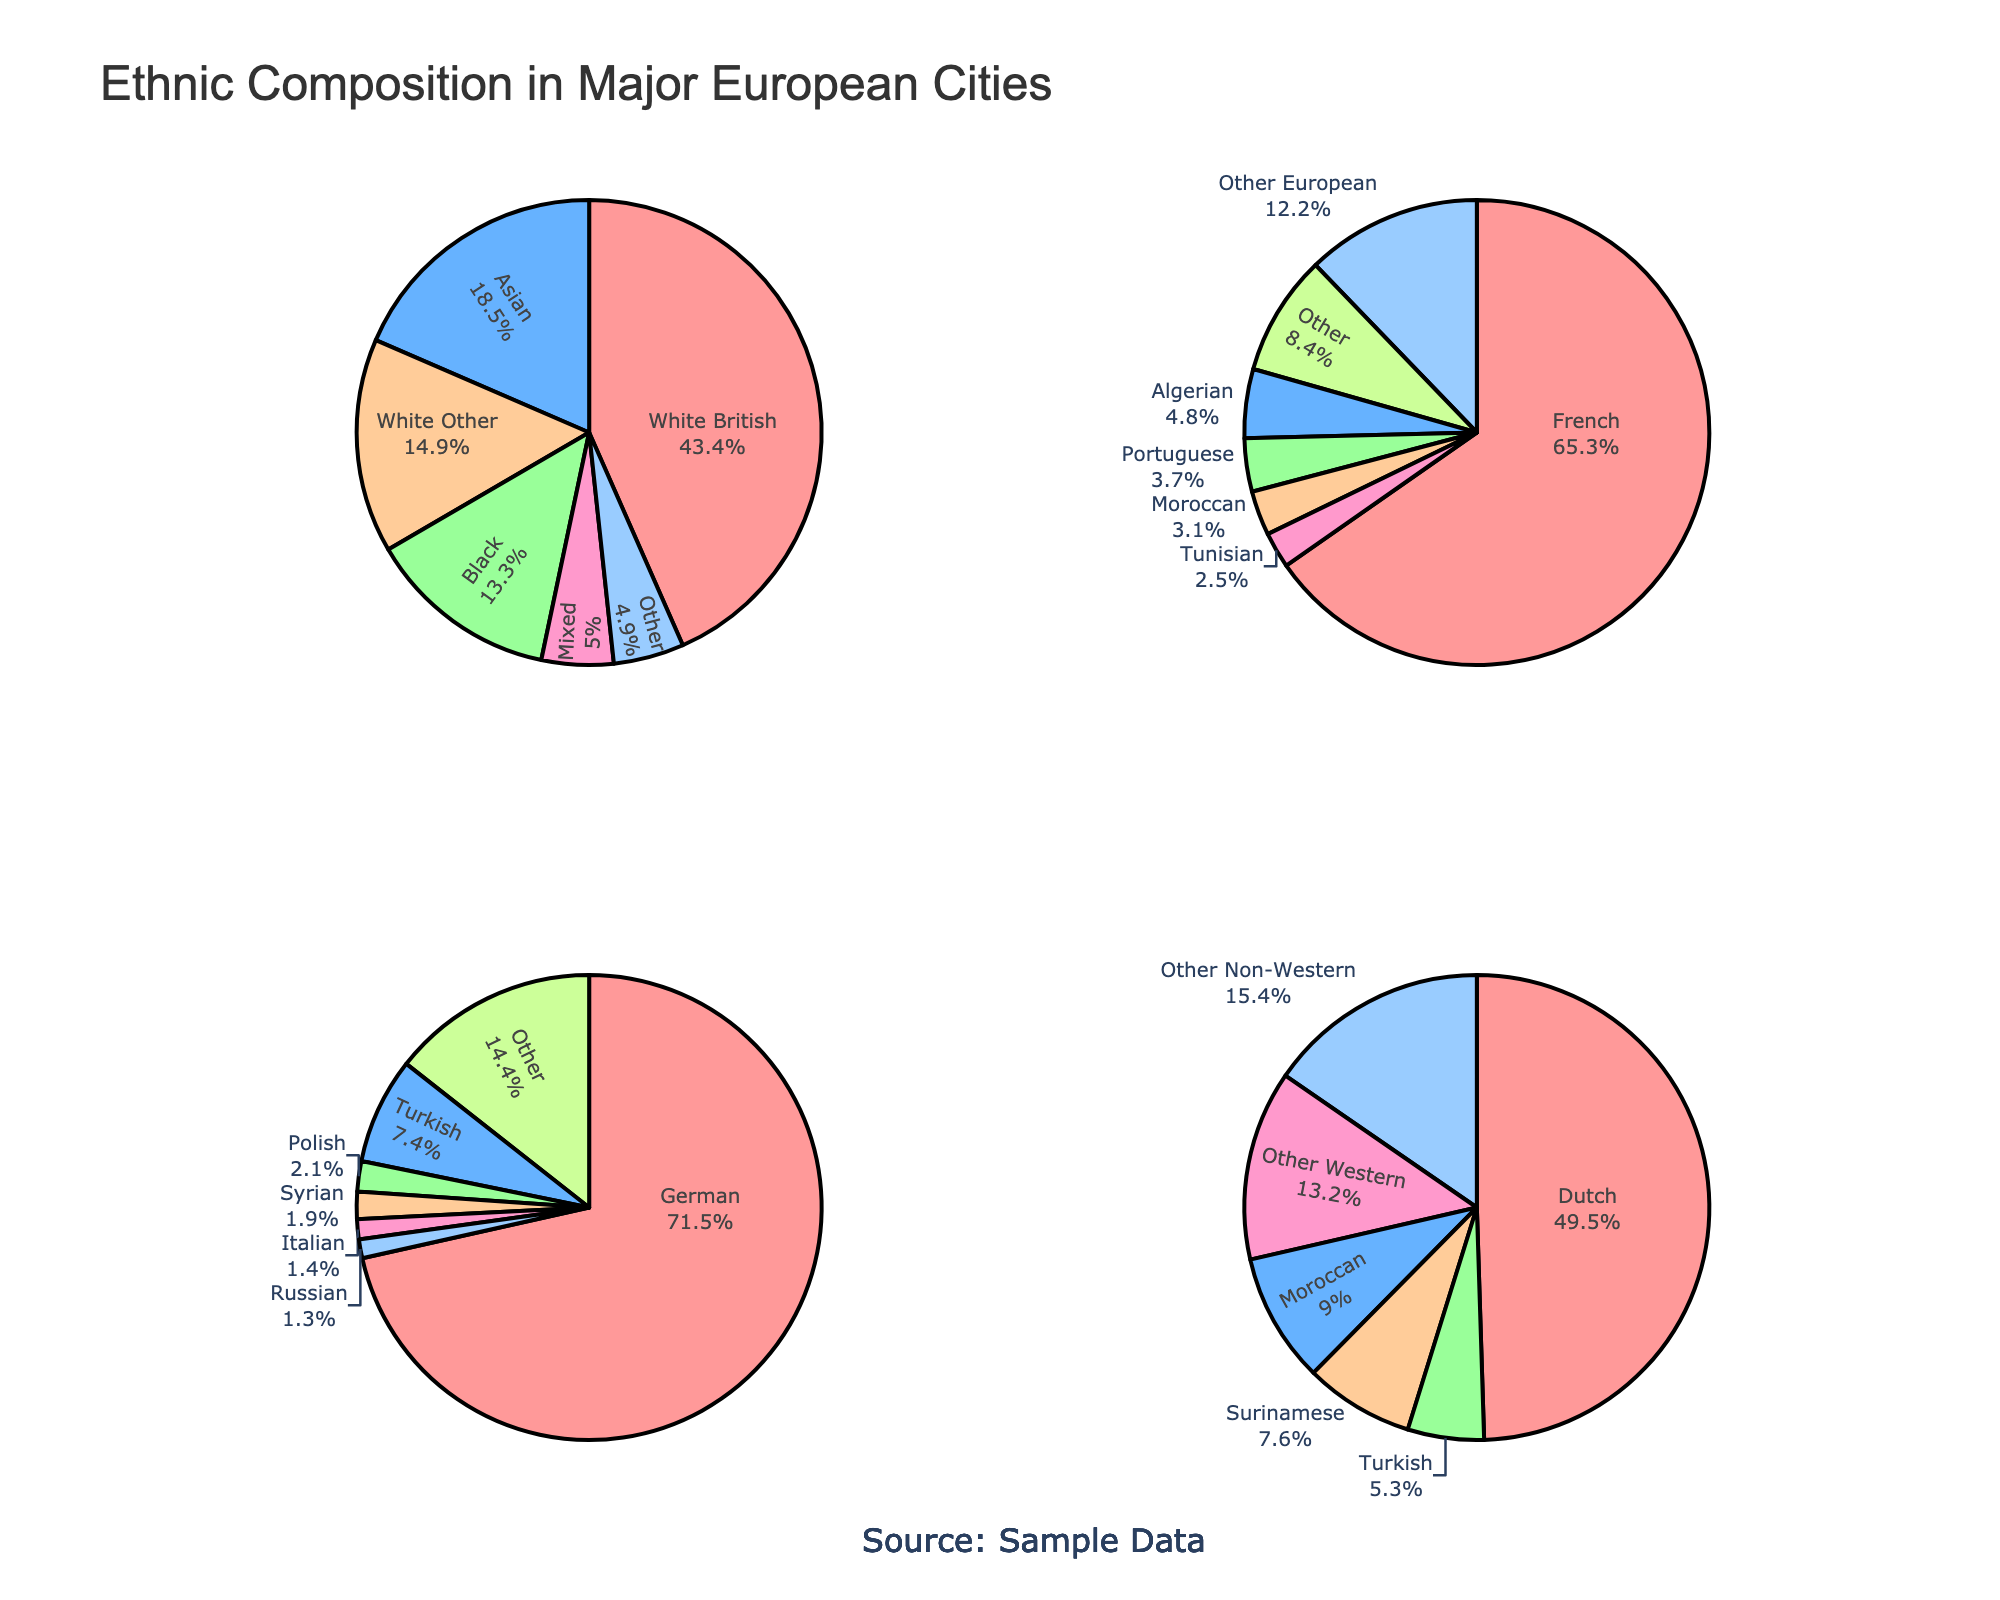What's the total percentage of ethnic groups categorized as "Other" in all four cities? To find the total percentage of ethnic groups categorized as "Other" for each city, we sum up the percentages: London (4.9), Paris (8.4), Berlin (14.4), and Amsterdam (15.4). Adding these values gives 4.9 + 8.4 + 14.4 + 15.4 = 43.1.
Answer: 43.1% Which city has the highest percentage of its largest ethnic group? London has 43.4% White British, Paris has 65.3% French, Berlin has 71.5% German, Amsterdam has 49.5% Dutch. Berlin has the highest percentage of its largest ethnic group at 71.5%.
Answer: Berlin How does the percentage of the Turkish ethnic group in Berlin compare to that in Amsterdam? The Turkish ethnic group is 7.4% in Berlin and 5.3% in Amsterdam. Hence, the percentage in Berlin is higher.
Answer: Berlin What is the combined percentage of "White Other" and "Mixed" ethnic groups in London? In London, "White Other" is 14.9% and "Mixed" is 5.0%. Combining these gives 14.9 + 5.0 = 19.9%.
Answer: 19.9% Among the four cities, which one has the smallest percentage of its second-largest ethnic group? London's second-largest group is Asian (18.5%), Paris’s is Other European (12.2%), Berlin’s is Turkish (7.4%), and Amsterdam’s is Moroccan (9.0%). Berlin’s second-largest group has the smallest percentage at 7.4%.
Answer: Berlin Which ethnic group in Paris has roughly the same percentage as the "Black" ethnic group in London? The "Black" ethnic group in London is 13.3%. The closest group in Paris is the "Other European" with 12.2%.
Answer: Other European How does the percentage of the Algerian ethnic group in Paris compare to the Surinamese ethnic group in Amsterdam? The Algerian ethnic group in Paris is 4.8% and the Surinamese ethnic group in Amsterdam is 7.6%. The percentage in Amsterdam is higher.
Answer: Amsterdam What is the percentage difference between the "Dutch" ethnic group in Amsterdam and the "White British" ethnic group in London? The "Dutch" in Amsterdam are 49.5% and the "White British" in London are 43.4%. The difference is 49.5 - 43.4 = 6.1%.
Answer: 6.1% If you combine the percentages of the "Other Non-Western" ethnic group in Amsterdam and the "Other" ethnic group in Berlin, what is their total percentage? "Other Non-Western" in Amsterdam is 15.4% and "Other" in Berlin is 14.4%. Combined, they are 15.4 + 14.4 = 29.8%.
Answer: 29.8% Which group has the least representation in all cities combined? The smallest groups are the "Italian" in Berlin (1.4%) and "Russian" in Berlin (1.3%). The "Russian" group in Berlin has the least representation at 1.3%.
Answer: Russian in Berlin 